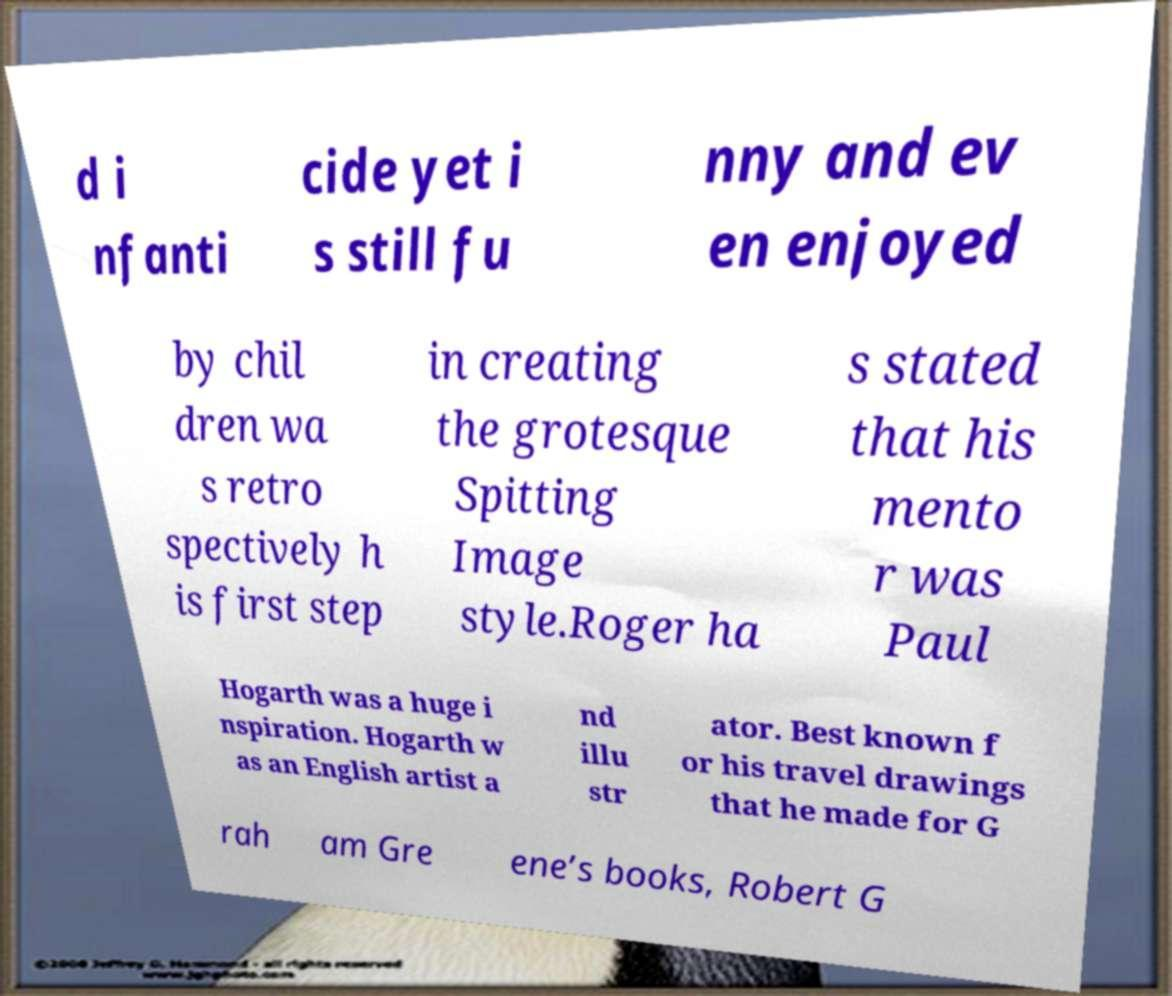Please identify and transcribe the text found in this image. d i nfanti cide yet i s still fu nny and ev en enjoyed by chil dren wa s retro spectively h is first step in creating the grotesque Spitting Image style.Roger ha s stated that his mento r was Paul Hogarth was a huge i nspiration. Hogarth w as an English artist a nd illu str ator. Best known f or his travel drawings that he made for G rah am Gre ene’s books, Robert G 